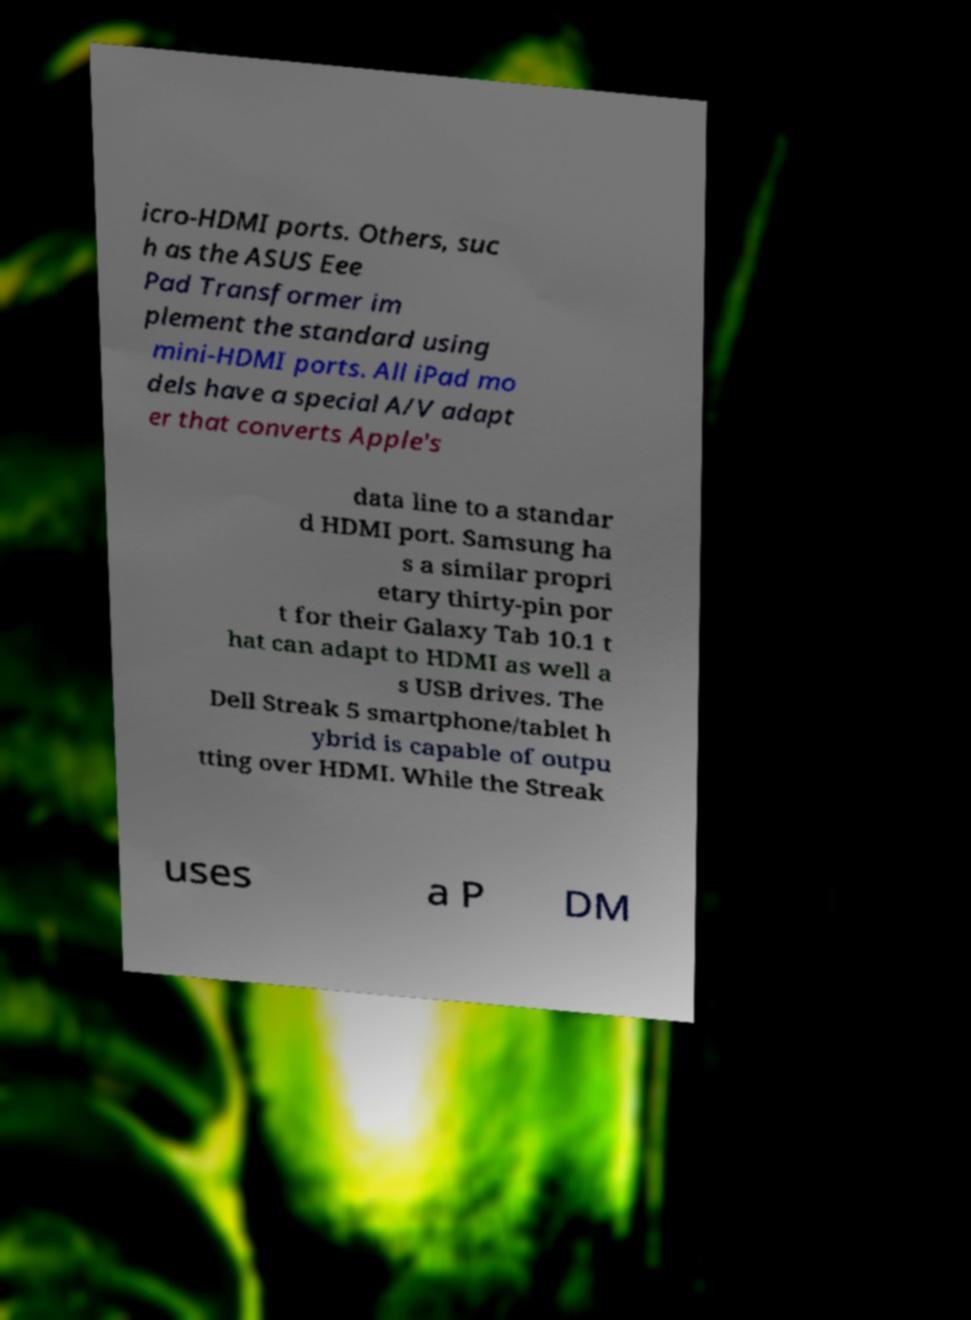Please identify and transcribe the text found in this image. icro-HDMI ports. Others, suc h as the ASUS Eee Pad Transformer im plement the standard using mini-HDMI ports. All iPad mo dels have a special A/V adapt er that converts Apple's data line to a standar d HDMI port. Samsung ha s a similar propri etary thirty-pin por t for their Galaxy Tab 10.1 t hat can adapt to HDMI as well a s USB drives. The Dell Streak 5 smartphone/tablet h ybrid is capable of outpu tting over HDMI. While the Streak uses a P DM 